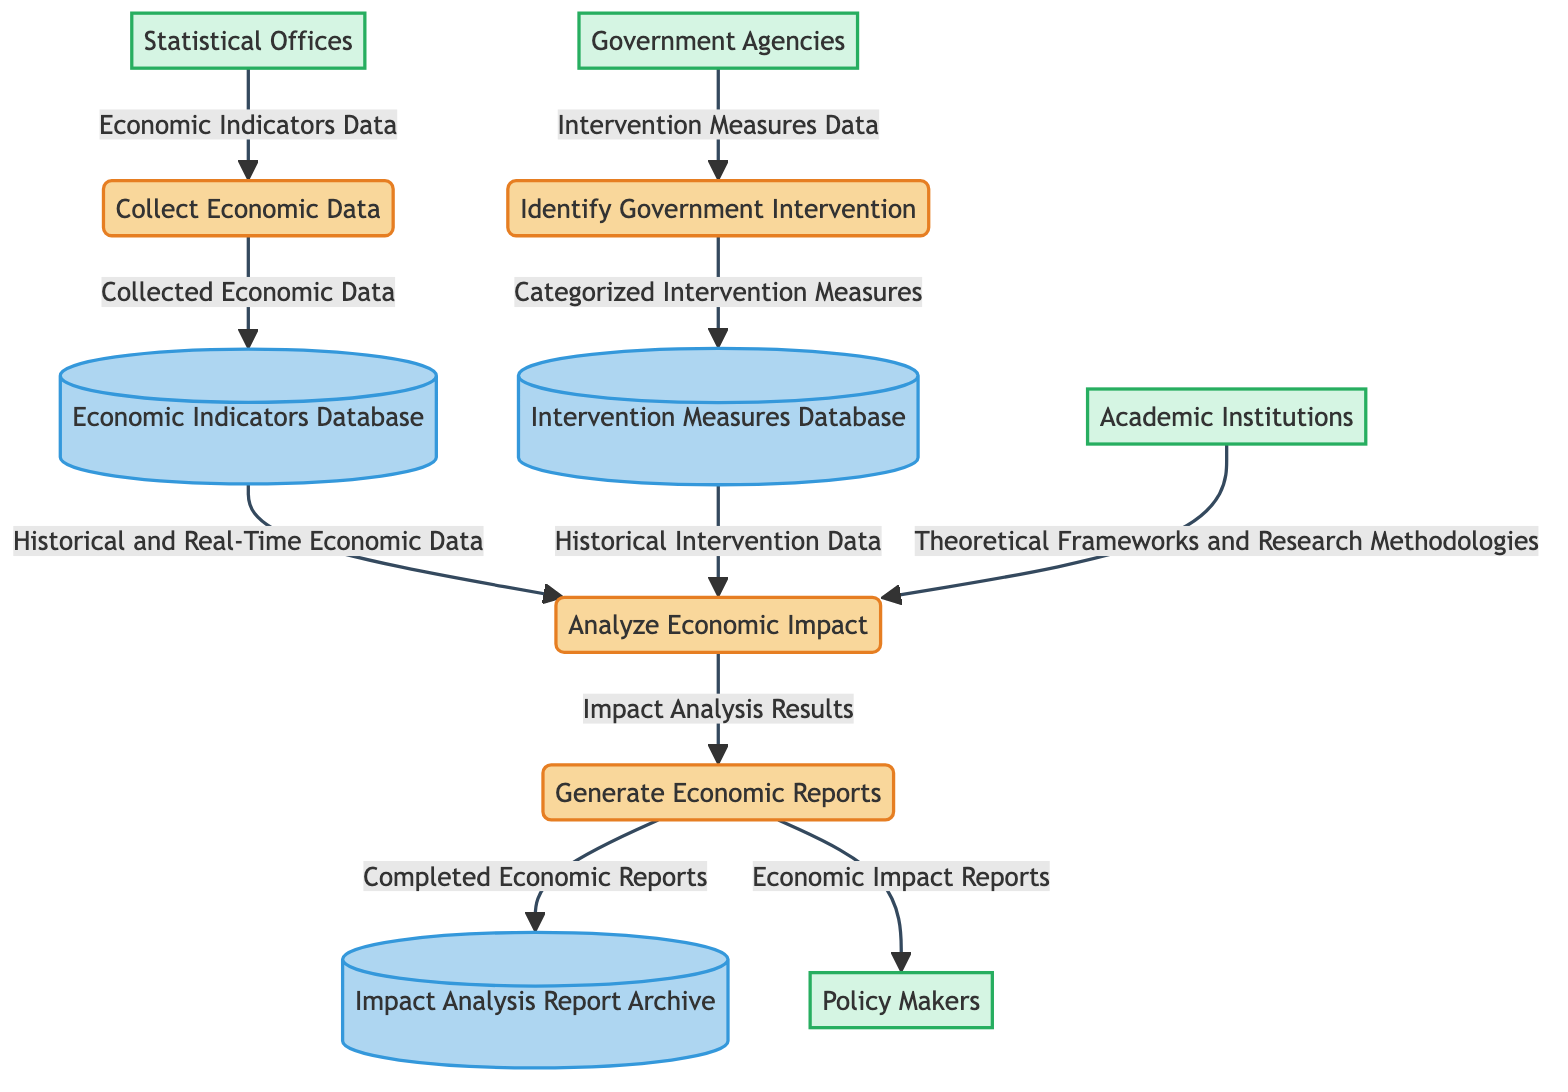What is the first process in the diagram? The first process listed in the diagram is “Identify Government Intervention.” This can be found at the beginning of the sequence of processes that analyze government intervention in the free market.
Answer: Identify Government Intervention How many external entities are present in the diagram? There are four external entities depicted in the diagram: Government Agencies, Statistical Offices, Academic Institutions, and Policy Makers. This count is determined by simply counting the unique entities brought into the diagram.
Answer: 4 What type of data flows into the “Collect Economic Data” process? The data that flows into the “Collect Economic Data” process comes from Statistical Offices, specifically labeled as “Economic Indicators Data.” This is identified by tracking the arrows leading into the process.
Answer: Economic Indicators Data What process generates reports intended for policy makers? The process that generates reports for policy makers is “Generate Economic Reports.” It is specifically shown to output “Economic Impact Reports” directed to the Policy Makers entity.
Answer: Generate Economic Reports Which data store receives data from "Collect Economic Data"? The data store that receives data from “Collect Economic Data” is the “Economic Indicators Database.” The data flow from the process indicates that “Collected Economic Data” is stored here.
Answer: Economic Indicators Database What influences the “Analyze Economic Impact” process? The process “Analyze Economic Impact” is influenced by both the “Economic Indicators Database,” which feeds it historical and real-time economic data, and the “Intervention Measures Database,” which provides historical intervention data. Each of these data flows contributes to the analysis conducted by the process.
Answer: Economic Indicators Database and Intervention Measures Database How many processes are there in total in the diagram? There are four processes in total, identified as: Identify Government Intervention, Collect Economic Data, Analyze Economic Impact, and Generate Economic Reports. Counting these provides the total number of stated processes.
Answer: 4 What information does the “Generate Economic Reports” process output? The “Generate Economic Reports” process outputs “Completed Economic Reports” to the Impact Analysis Report Archive and “Economic Impact Reports” to Policy Makers, as indicated by the arrows leading away from this process.
Answer: Completed Economic Reports and Economic Impact Reports What type of database contains historical intervention data? The type of database that contains historical intervention data is the “Intervention Measures Database.” This is established by tracing the data flow that leads from this store to the Analyze Economic Impact process.
Answer: Intervention Measures Database 